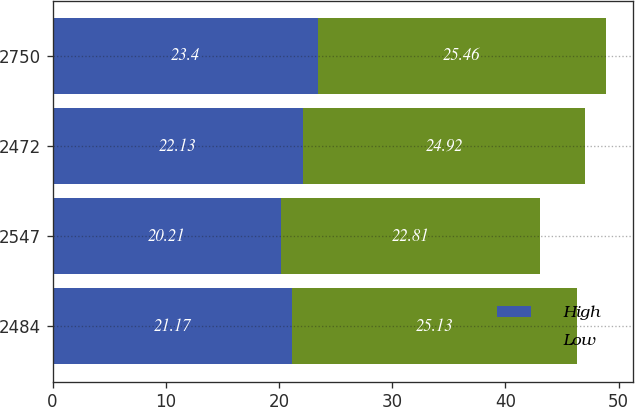Convert chart to OTSL. <chart><loc_0><loc_0><loc_500><loc_500><stacked_bar_chart><ecel><fcel>2484<fcel>2547<fcel>2472<fcel>2750<nl><fcel>High<fcel>21.17<fcel>20.21<fcel>22.13<fcel>23.4<nl><fcel>Low<fcel>25.13<fcel>22.81<fcel>24.92<fcel>25.46<nl></chart> 